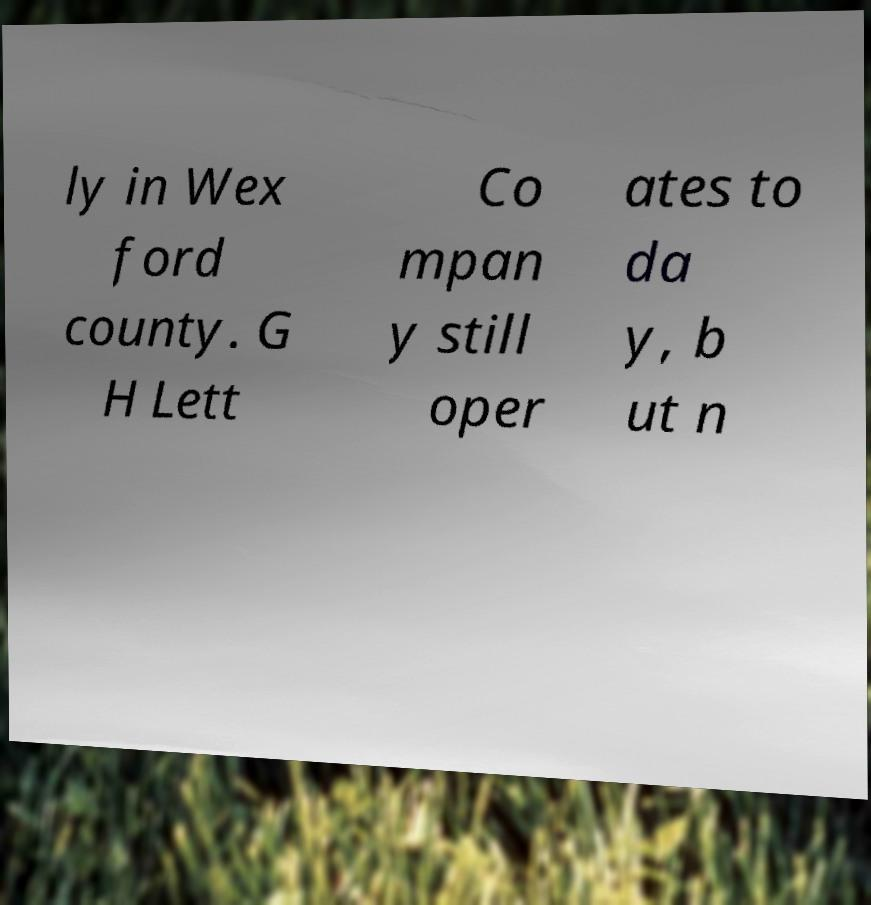Please read and relay the text visible in this image. What does it say? ly in Wex ford county. G H Lett Co mpan y still oper ates to da y, b ut n 